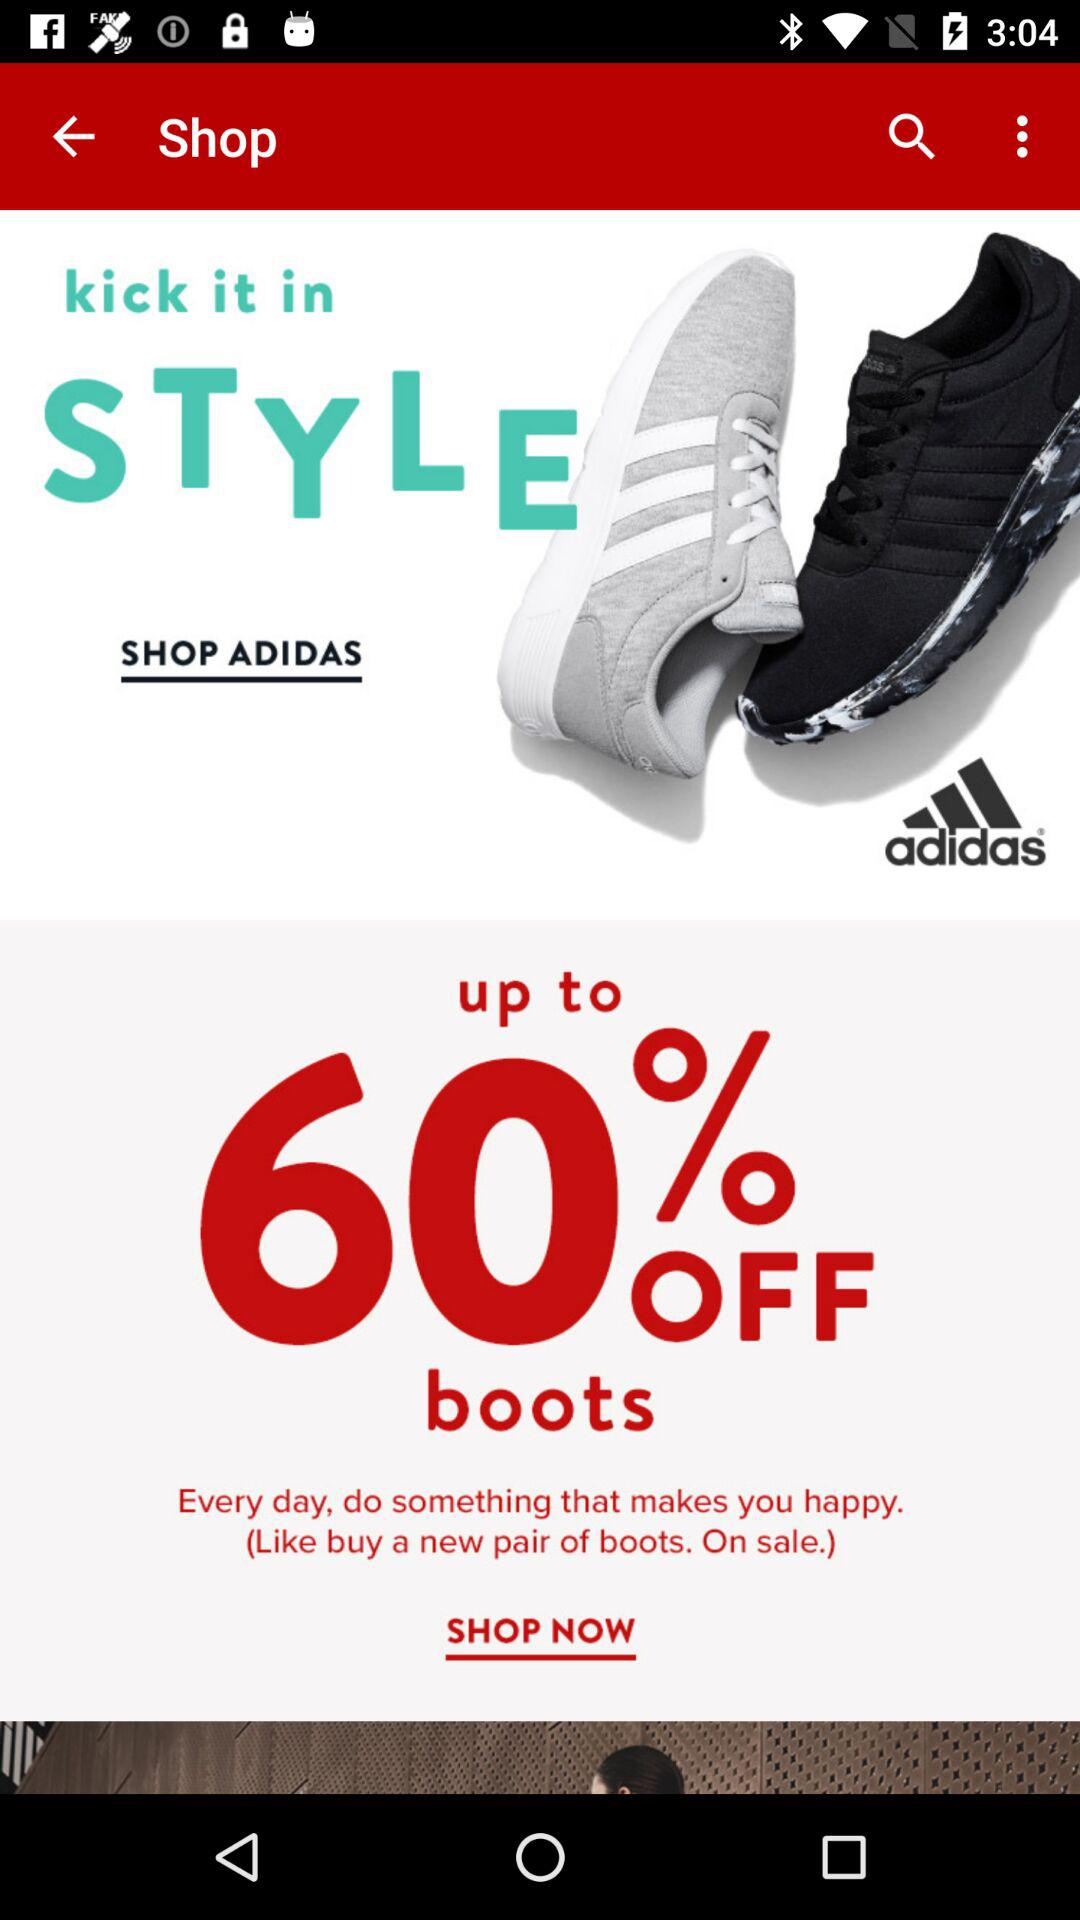What is the maximum discount on boots? The maximum discount on boots is 60%. 